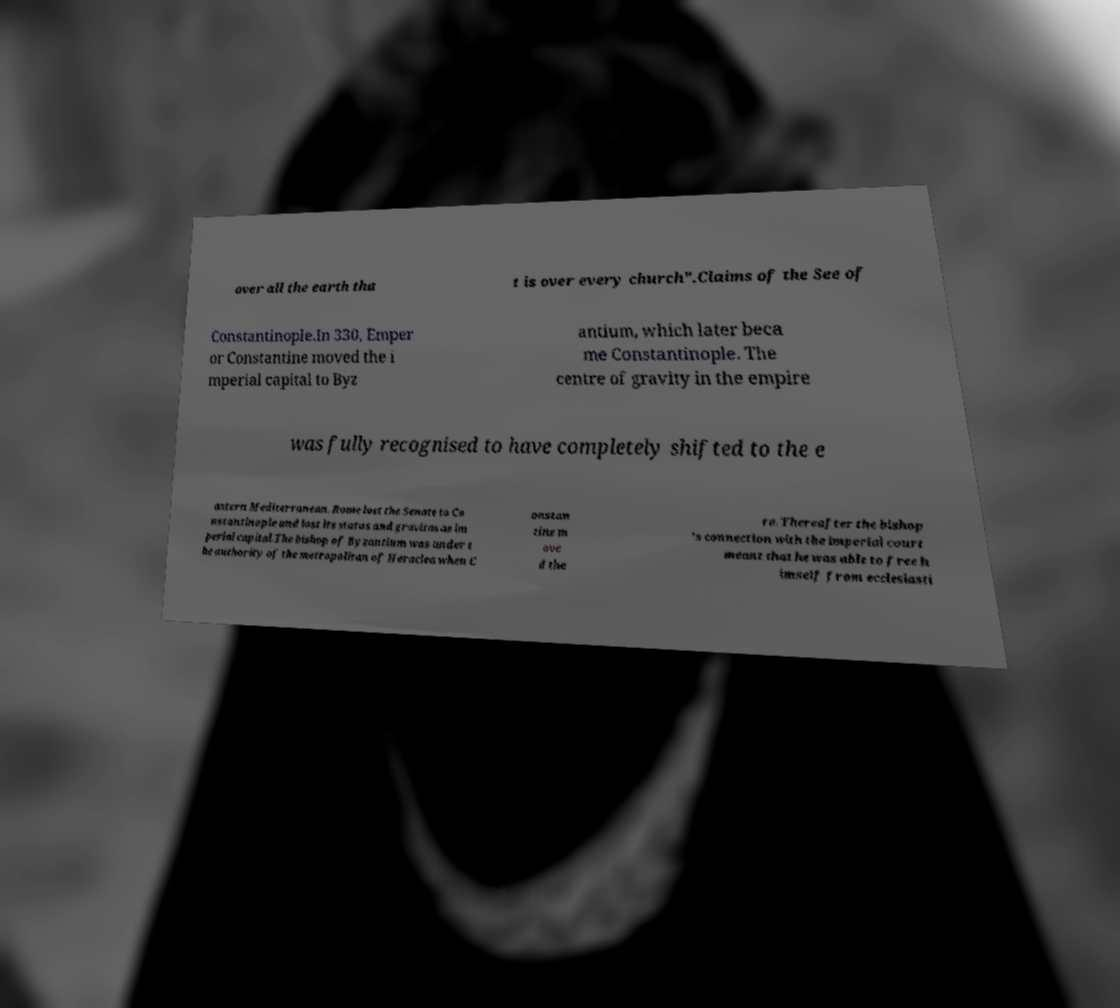Can you accurately transcribe the text from the provided image for me? over all the earth tha t is over every church".Claims of the See of Constantinople.In 330, Emper or Constantine moved the i mperial capital to Byz antium, which later beca me Constantinople. The centre of gravity in the empire was fully recognised to have completely shifted to the e astern Mediterranean. Rome lost the Senate to Co nstantinople and lost its status and gravitas as im perial capital.The bishop of Byzantium was under t he authority of the metropolitan of Heraclea when C onstan tine m ove d the re. Thereafter the bishop 's connection with the imperial court meant that he was able to free h imself from ecclesiasti 